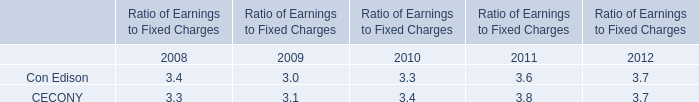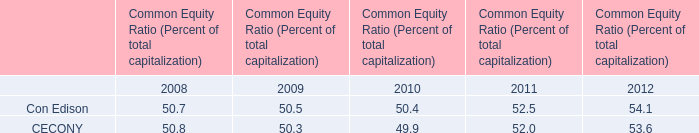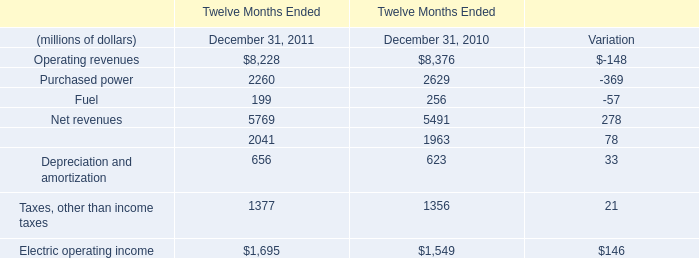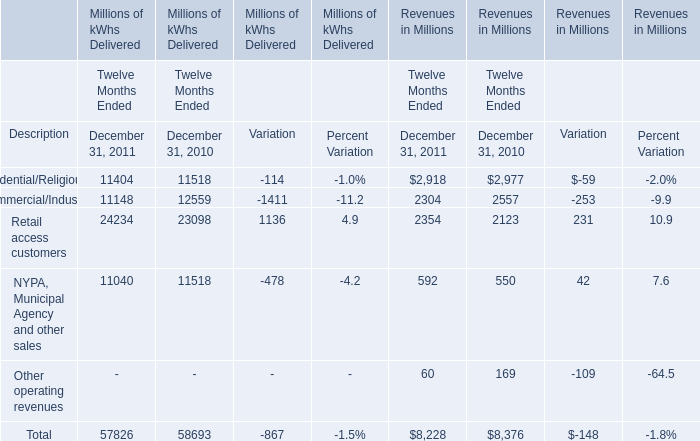In the year with lowest amount of Operating revenues, what's the increasing rate of Electric operating income? 
Computations: ((1695 - 1549) / 1549)
Answer: 0.09425. 